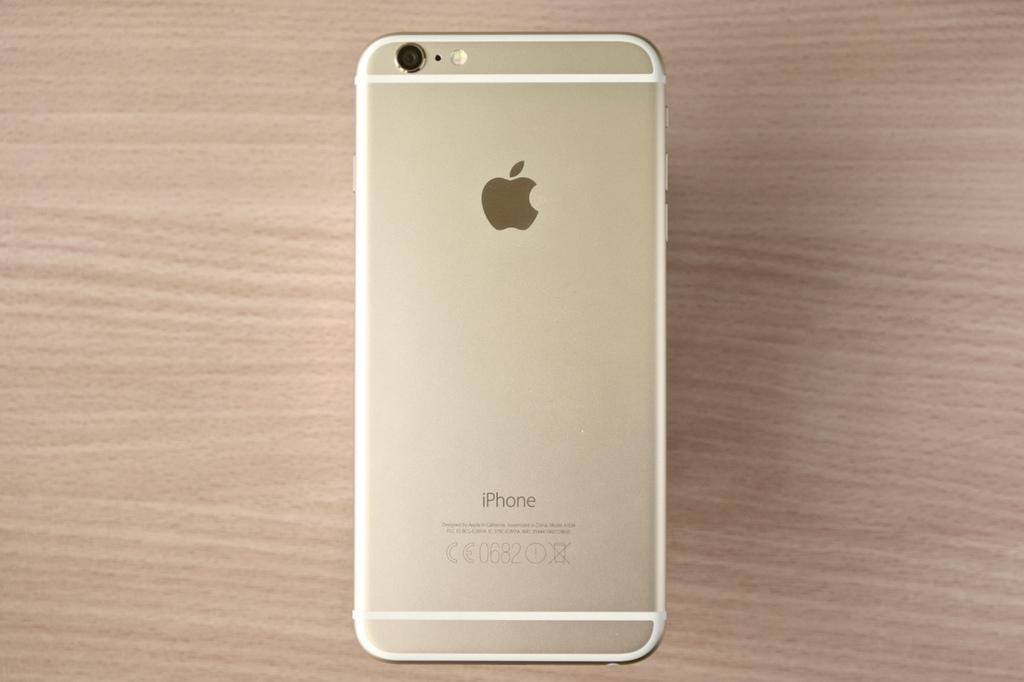<image>
Provide a brief description of the given image. a gold iPhone is turned upside down on a wooden surface 